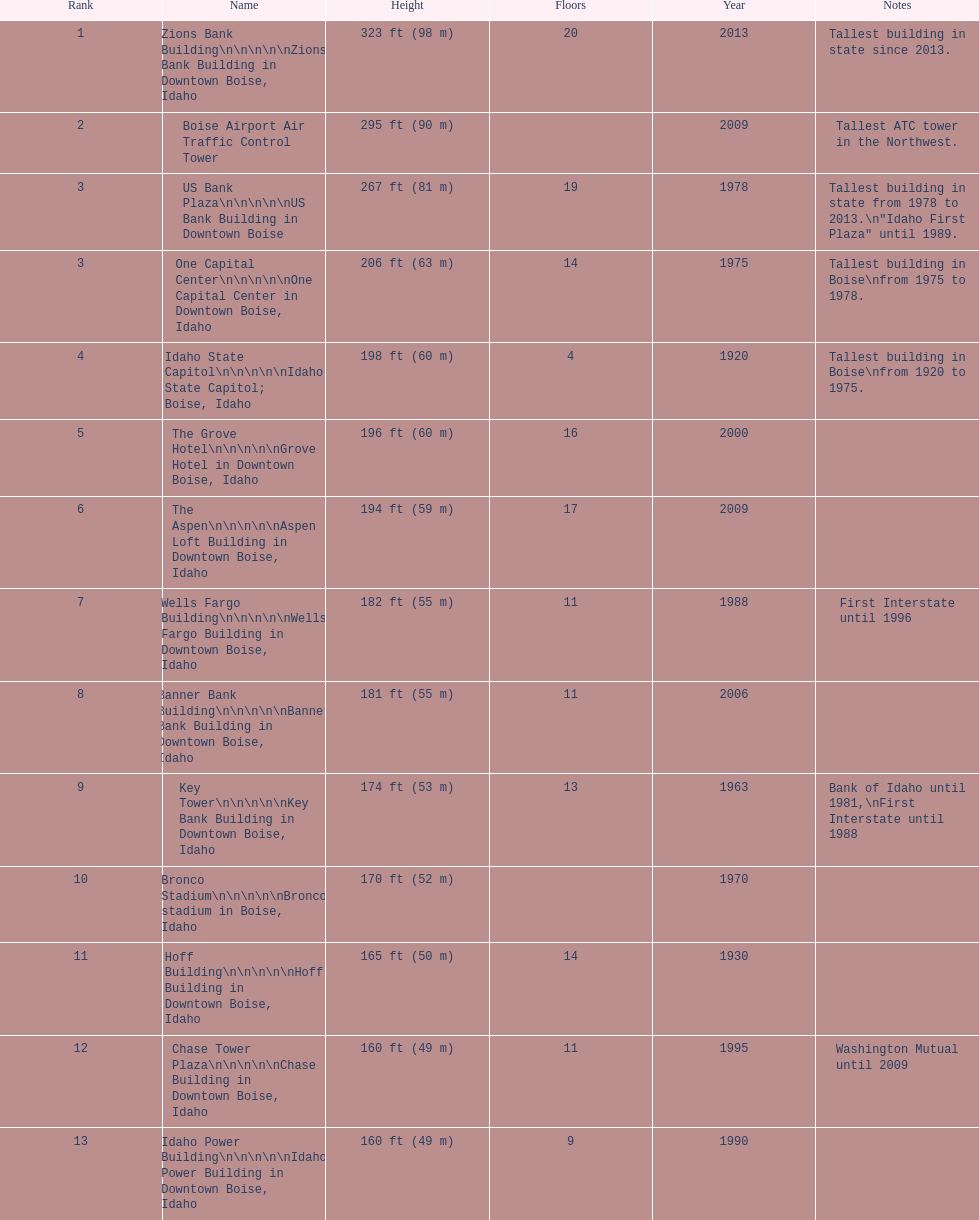What is the name of the building listed after idaho state capitol? The Grove Hotel. 